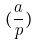<formula> <loc_0><loc_0><loc_500><loc_500>( \frac { a } { p } )</formula> 